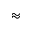<formula> <loc_0><loc_0><loc_500><loc_500>\approx</formula> 